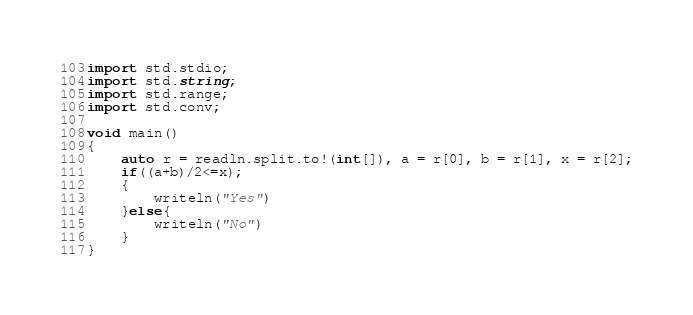Convert code to text. <code><loc_0><loc_0><loc_500><loc_500><_D_>import std.stdio;
import std.string;
import std.range;
import std.conv;

void main()
{
	auto r = readln.split.to!(int[]), a = r[0], b = r[1], x = r[2];
    if((a+b)/2<=x);
	{
		writeln("Yes")
	}else{
		writeln("No")
	}
}</code> 